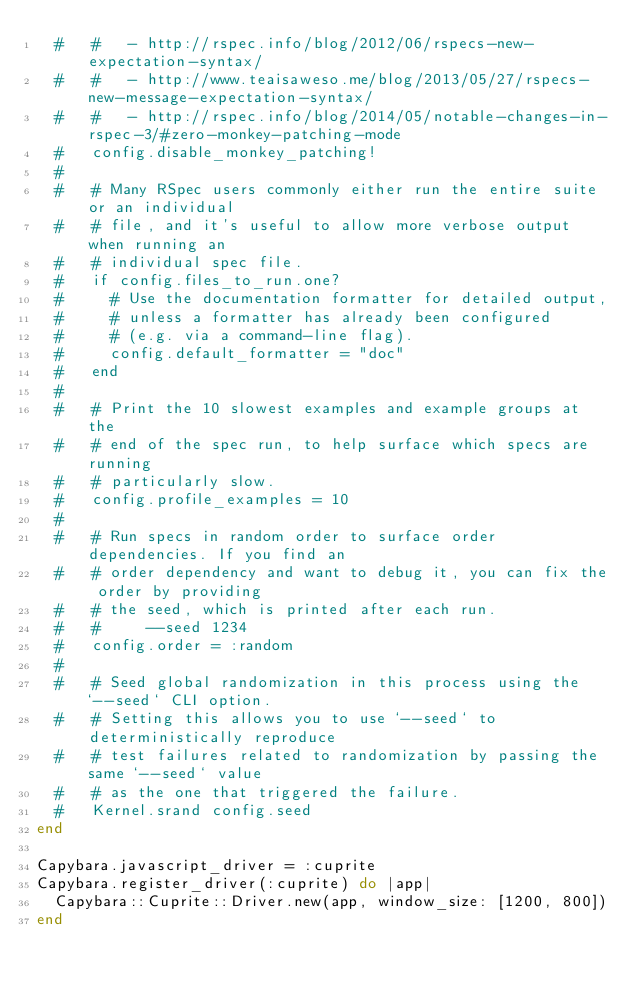<code> <loc_0><loc_0><loc_500><loc_500><_Ruby_>  #   #   - http://rspec.info/blog/2012/06/rspecs-new-expectation-syntax/
  #   #   - http://www.teaisaweso.me/blog/2013/05/27/rspecs-new-message-expectation-syntax/
  #   #   - http://rspec.info/blog/2014/05/notable-changes-in-rspec-3/#zero-monkey-patching-mode
  #   config.disable_monkey_patching!
  #
  #   # Many RSpec users commonly either run the entire suite or an individual
  #   # file, and it's useful to allow more verbose output when running an
  #   # individual spec file.
  #   if config.files_to_run.one?
  #     # Use the documentation formatter for detailed output,
  #     # unless a formatter has already been configured
  #     # (e.g. via a command-line flag).
  #     config.default_formatter = "doc"
  #   end
  #
  #   # Print the 10 slowest examples and example groups at the
  #   # end of the spec run, to help surface which specs are running
  #   # particularly slow.
  #   config.profile_examples = 10
  #
  #   # Run specs in random order to surface order dependencies. If you find an
  #   # order dependency and want to debug it, you can fix the order by providing
  #   # the seed, which is printed after each run.
  #   #     --seed 1234
  #   config.order = :random
  #
  #   # Seed global randomization in this process using the `--seed` CLI option.
  #   # Setting this allows you to use `--seed` to deterministically reproduce
  #   # test failures related to randomization by passing the same `--seed` value
  #   # as the one that triggered the failure.
  #   Kernel.srand config.seed
end

Capybara.javascript_driver = :cuprite
Capybara.register_driver(:cuprite) do |app|
  Capybara::Cuprite::Driver.new(app, window_size: [1200, 800])
end
</code> 